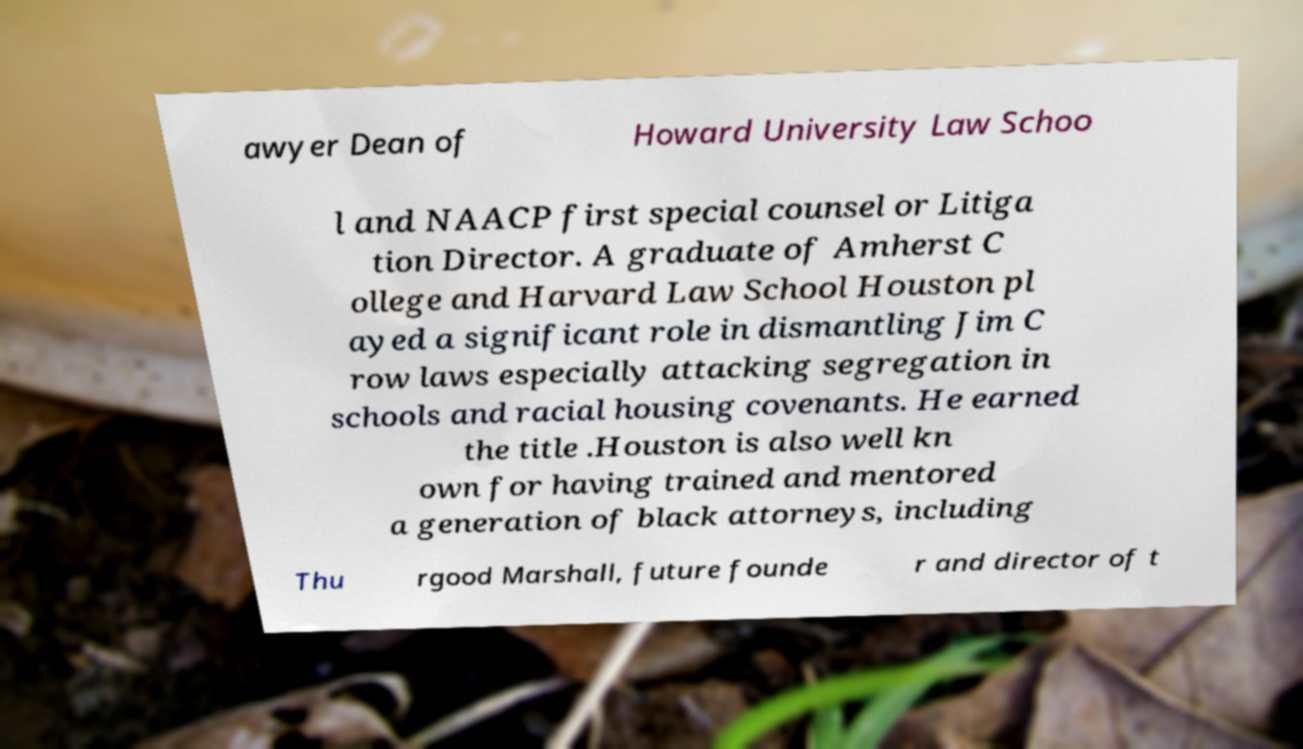I need the written content from this picture converted into text. Can you do that? awyer Dean of Howard University Law Schoo l and NAACP first special counsel or Litiga tion Director. A graduate of Amherst C ollege and Harvard Law School Houston pl ayed a significant role in dismantling Jim C row laws especially attacking segregation in schools and racial housing covenants. He earned the title .Houston is also well kn own for having trained and mentored a generation of black attorneys, including Thu rgood Marshall, future founde r and director of t 